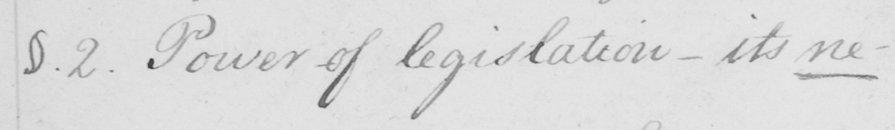Can you read and transcribe this handwriting? §.2 . Power of legislation  _  its ne- 